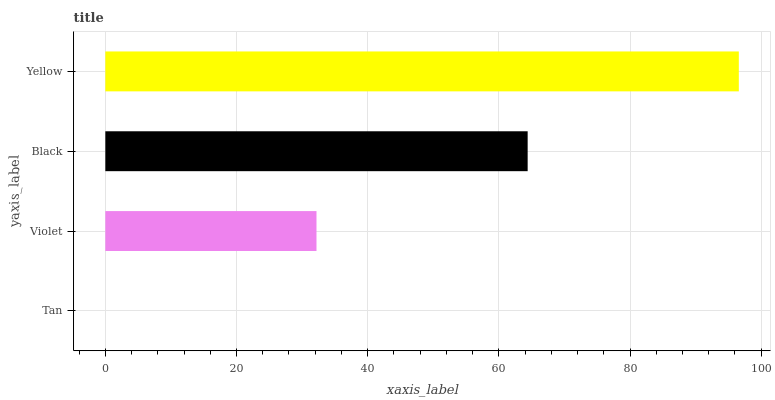Is Tan the minimum?
Answer yes or no. Yes. Is Yellow the maximum?
Answer yes or no. Yes. Is Violet the minimum?
Answer yes or no. No. Is Violet the maximum?
Answer yes or no. No. Is Violet greater than Tan?
Answer yes or no. Yes. Is Tan less than Violet?
Answer yes or no. Yes. Is Tan greater than Violet?
Answer yes or no. No. Is Violet less than Tan?
Answer yes or no. No. Is Black the high median?
Answer yes or no. Yes. Is Violet the low median?
Answer yes or no. Yes. Is Tan the high median?
Answer yes or no. No. Is Tan the low median?
Answer yes or no. No. 